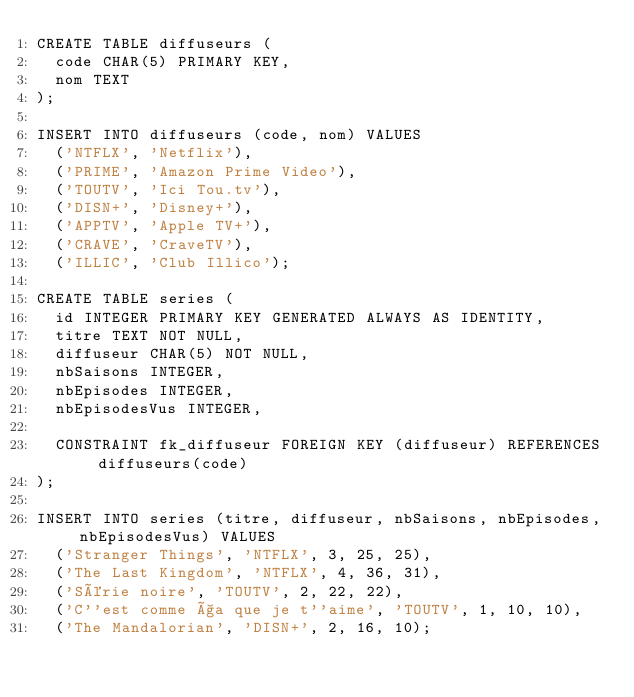Convert code to text. <code><loc_0><loc_0><loc_500><loc_500><_SQL_>CREATE TABLE diffuseurs (
	code CHAR(5) PRIMARY KEY,
	nom TEXT
);

INSERT INTO diffuseurs (code, nom) VALUES
	('NTFLX', 'Netflix'),
	('PRIME', 'Amazon Prime Video'),
	('TOUTV', 'Ici Tou.tv'),
	('DISN+', 'Disney+'),
	('APPTV', 'Apple TV+'),
	('CRAVE', 'CraveTV'),
	('ILLIC', 'Club Illico');

CREATE TABLE series (
	id INTEGER PRIMARY KEY GENERATED ALWAYS AS IDENTITY,
	titre TEXT NOT NULL,
	diffuseur CHAR(5) NOT NULL,
	nbSaisons INTEGER,
	nbEpisodes INTEGER,
	nbEpisodesVus INTEGER,
	
	CONSTRAINT fk_diffuseur FOREIGN KEY (diffuseur) REFERENCES diffuseurs(code)
);

INSERT INTO series (titre, diffuseur, nbSaisons, nbEpisodes, nbEpisodesVus) VALUES
	('Stranger Things', 'NTFLX', 3, 25, 25),
	('The Last Kingdom', 'NTFLX', 4, 36, 31),
	('Série noire', 'TOUTV', 2, 22, 22),
	('C''est comme ça que je t''aime', 'TOUTV', 1, 10, 10),
	('The Mandalorian', 'DISN+', 2, 16, 10);
</code> 